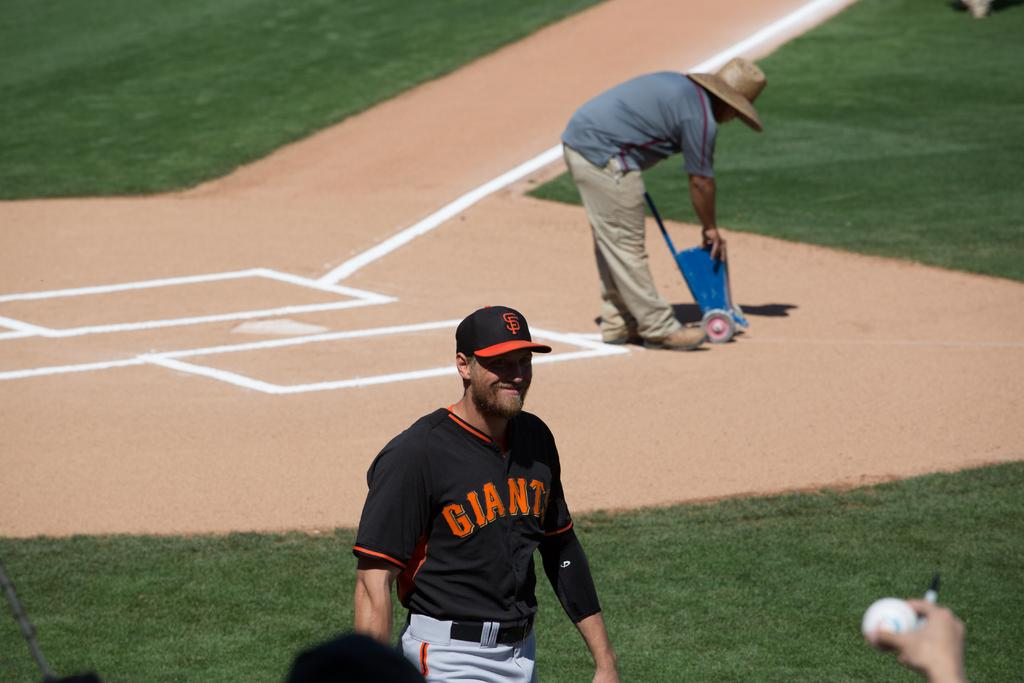<image>
Share a concise interpretation of the image provided. A man in a black Giants uniform smiles on a baseball field. 